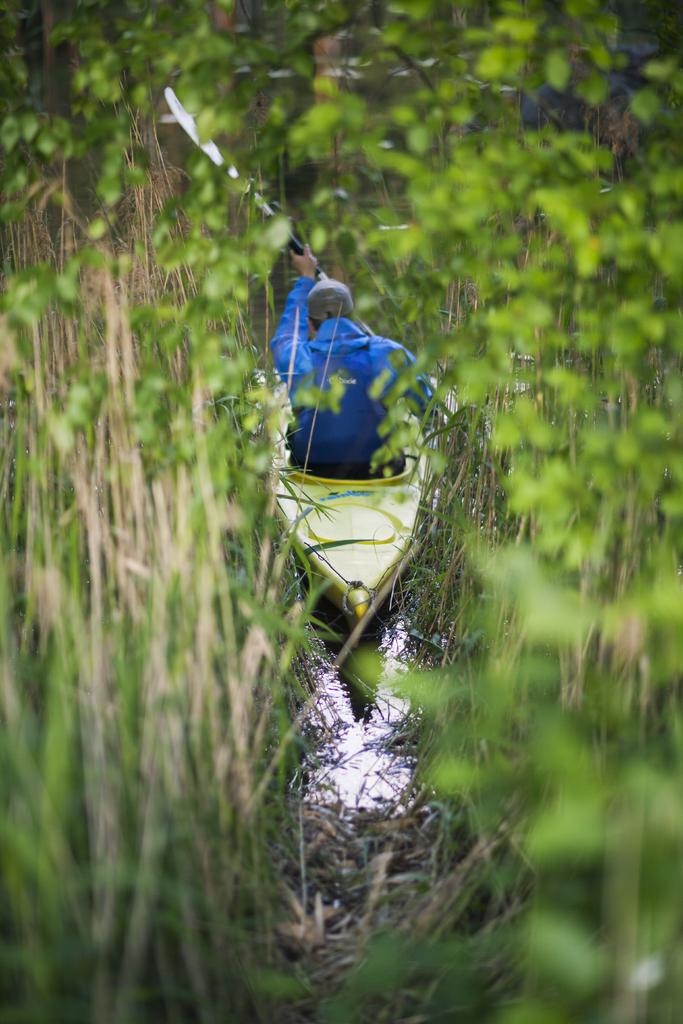Who is present in the image? There is a person in the image. What is the person doing in the image? The person is on a boat. What is the location of the boat in the image? The boat is in between plants. What is the person holding in the image? The person is holding a rower. What type of skin condition can be seen on the person's face in the image? There is no skin condition visible on the person's face in the image. 